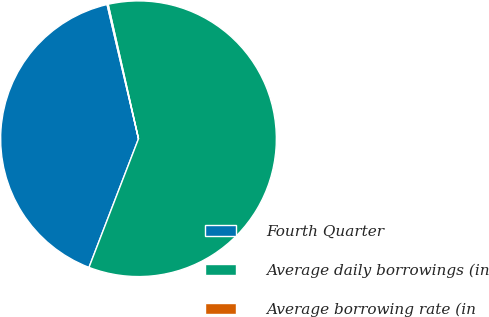<chart> <loc_0><loc_0><loc_500><loc_500><pie_chart><fcel>Fourth Quarter<fcel>Average daily borrowings (in<fcel>Average borrowing rate (in<nl><fcel>40.49%<fcel>59.38%<fcel>0.13%<nl></chart> 